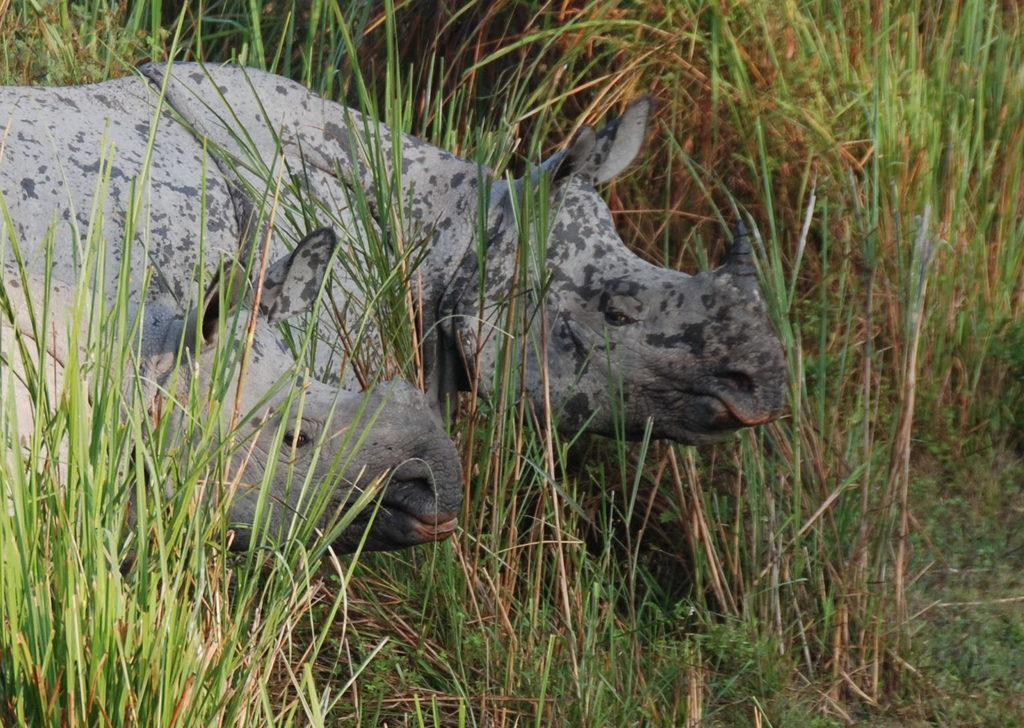Describe this image in one or two sentences. In the image we can see there are two hippopotamus standing on the ground and there are plants and grass on the ground. 